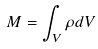<formula> <loc_0><loc_0><loc_500><loc_500>M = \int _ { V } \rho d V</formula> 